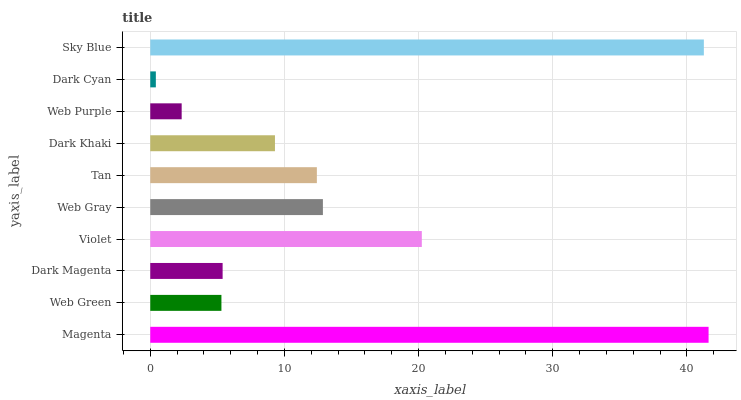Is Dark Cyan the minimum?
Answer yes or no. Yes. Is Magenta the maximum?
Answer yes or no. Yes. Is Web Green the minimum?
Answer yes or no. No. Is Web Green the maximum?
Answer yes or no. No. Is Magenta greater than Web Green?
Answer yes or no. Yes. Is Web Green less than Magenta?
Answer yes or no. Yes. Is Web Green greater than Magenta?
Answer yes or no. No. Is Magenta less than Web Green?
Answer yes or no. No. Is Tan the high median?
Answer yes or no. Yes. Is Dark Khaki the low median?
Answer yes or no. Yes. Is Sky Blue the high median?
Answer yes or no. No. Is Web Gray the low median?
Answer yes or no. No. 